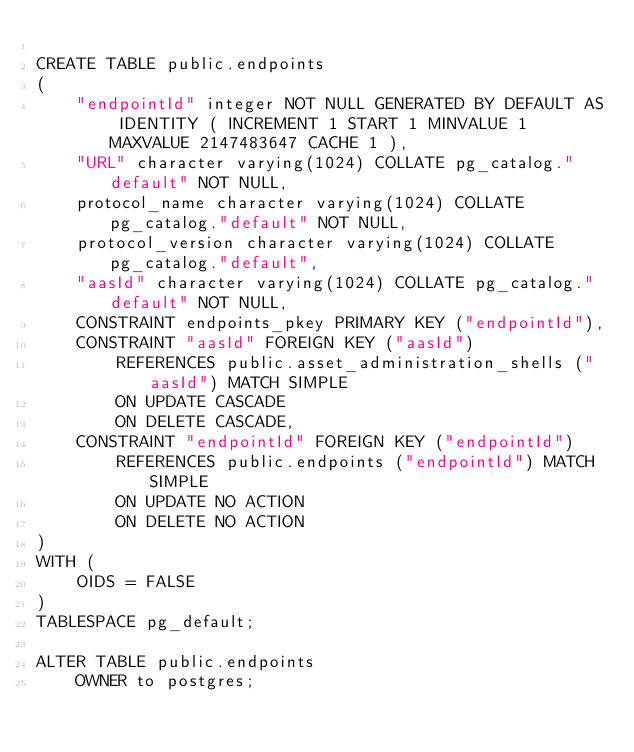<code> <loc_0><loc_0><loc_500><loc_500><_SQL_>
CREATE TABLE public.endpoints
(
    "endpointId" integer NOT NULL GENERATED BY DEFAULT AS IDENTITY ( INCREMENT 1 START 1 MINVALUE 1 MAXVALUE 2147483647 CACHE 1 ),
    "URL" character varying(1024) COLLATE pg_catalog."default" NOT NULL,
    protocol_name character varying(1024) COLLATE pg_catalog."default" NOT NULL,
    protocol_version character varying(1024) COLLATE pg_catalog."default",
    "aasId" character varying(1024) COLLATE pg_catalog."default" NOT NULL,
    CONSTRAINT endpoints_pkey PRIMARY KEY ("endpointId"),
    CONSTRAINT "aasId" FOREIGN KEY ("aasId")
        REFERENCES public.asset_administration_shells ("aasId") MATCH SIMPLE
        ON UPDATE CASCADE
        ON DELETE CASCADE,
    CONSTRAINT "endpointId" FOREIGN KEY ("endpointId")
        REFERENCES public.endpoints ("endpointId") MATCH SIMPLE
        ON UPDATE NO ACTION
        ON DELETE NO ACTION
)
WITH (
    OIDS = FALSE
)
TABLESPACE pg_default;

ALTER TABLE public.endpoints
    OWNER to postgres;
</code> 